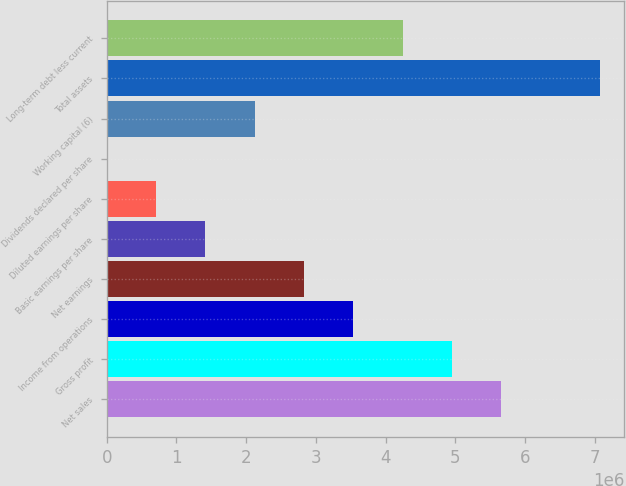<chart> <loc_0><loc_0><loc_500><loc_500><bar_chart><fcel>Net sales<fcel>Gross profit<fcel>Income from operations<fcel>Net earnings<fcel>Basic earnings per share<fcel>Diluted earnings per share<fcel>Dividends declared per share<fcel>Working capital (6)<fcel>Total assets<fcel>Long-term debt less current<nl><fcel>5.65688e+06<fcel>4.94977e+06<fcel>3.53555e+06<fcel>2.82844e+06<fcel>1.41422e+06<fcel>707111<fcel>0.58<fcel>2.12133e+06<fcel>7.0711e+06<fcel>4.24266e+06<nl></chart> 